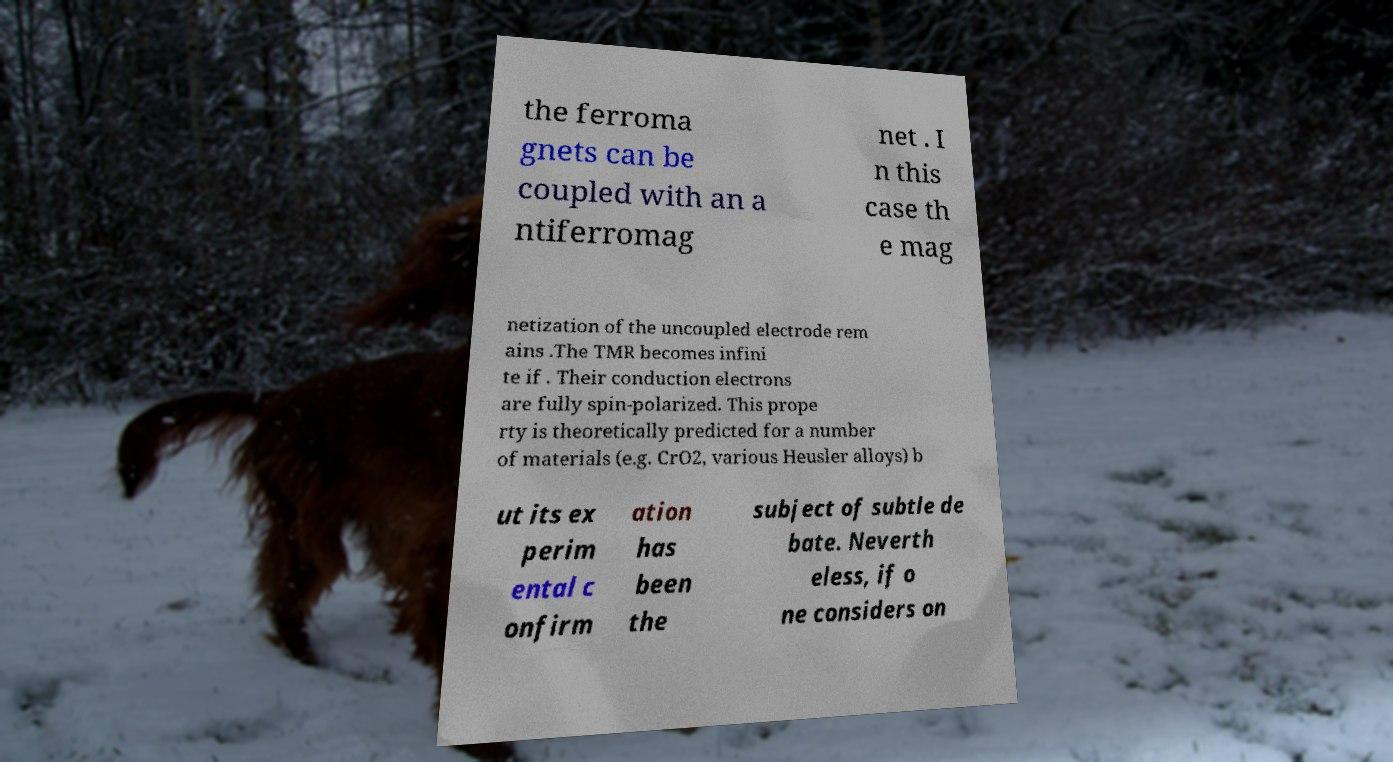Could you assist in decoding the text presented in this image and type it out clearly? the ferroma gnets can be coupled with an a ntiferromag net . I n this case th e mag netization of the uncoupled electrode rem ains .The TMR becomes infini te if . Their conduction electrons are fully spin-polarized. This prope rty is theoretically predicted for a number of materials (e.g. CrO2, various Heusler alloys) b ut its ex perim ental c onfirm ation has been the subject of subtle de bate. Neverth eless, if o ne considers on 